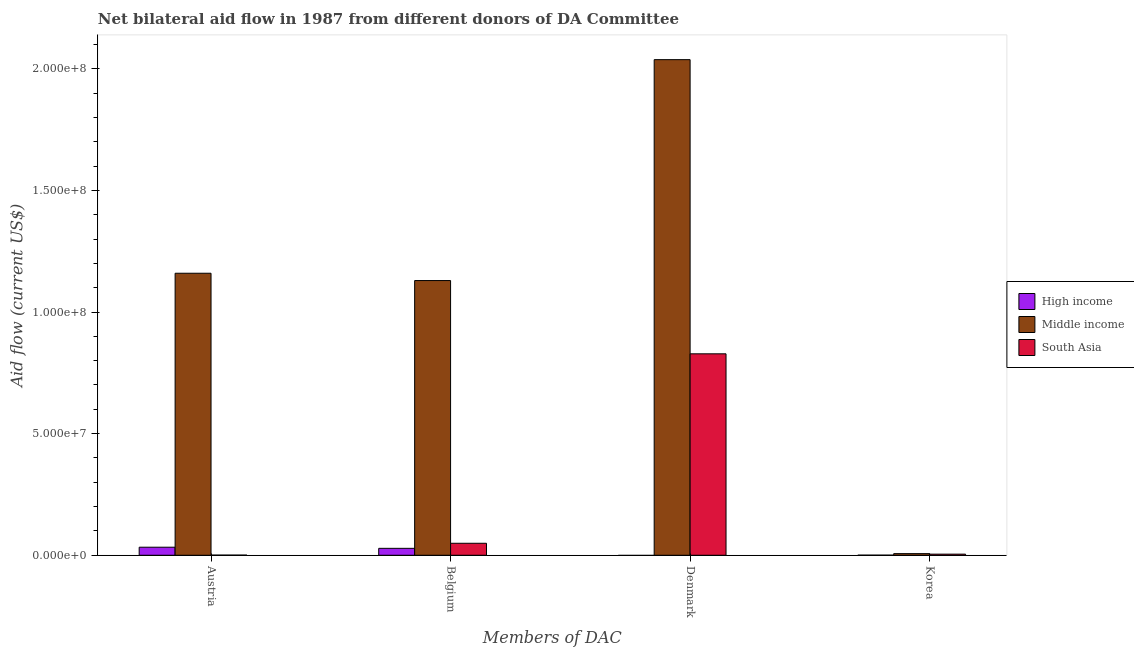Are the number of bars per tick equal to the number of legend labels?
Provide a succinct answer. No. Are the number of bars on each tick of the X-axis equal?
Provide a short and direct response. No. What is the amount of aid given by austria in South Asia?
Make the answer very short. 6.00e+04. Across all countries, what is the maximum amount of aid given by denmark?
Make the answer very short. 2.04e+08. Across all countries, what is the minimum amount of aid given by belgium?
Your answer should be very brief. 2.85e+06. What is the total amount of aid given by austria in the graph?
Offer a terse response. 1.19e+08. What is the difference between the amount of aid given by belgium in Middle income and that in South Asia?
Offer a very short reply. 1.08e+08. What is the difference between the amount of aid given by denmark in Middle income and the amount of aid given by austria in South Asia?
Provide a succinct answer. 2.04e+08. What is the average amount of aid given by denmark per country?
Your response must be concise. 9.55e+07. What is the difference between the amount of aid given by korea and amount of aid given by denmark in South Asia?
Keep it short and to the point. -8.24e+07. What is the ratio of the amount of aid given by korea in South Asia to that in Middle income?
Offer a terse response. 0.69. What is the difference between the highest and the second highest amount of aid given by belgium?
Your answer should be very brief. 1.08e+08. What is the difference between the highest and the lowest amount of aid given by korea?
Keep it short and to the point. 6.30e+05. In how many countries, is the amount of aid given by belgium greater than the average amount of aid given by belgium taken over all countries?
Give a very brief answer. 1. How many bars are there?
Make the answer very short. 11. Are all the bars in the graph horizontal?
Offer a terse response. No. What is the difference between two consecutive major ticks on the Y-axis?
Provide a short and direct response. 5.00e+07. Are the values on the major ticks of Y-axis written in scientific E-notation?
Keep it short and to the point. Yes. Does the graph contain any zero values?
Your answer should be compact. Yes. Does the graph contain grids?
Offer a terse response. No. Where does the legend appear in the graph?
Your answer should be very brief. Center right. How many legend labels are there?
Provide a short and direct response. 3. What is the title of the graph?
Your answer should be compact. Net bilateral aid flow in 1987 from different donors of DA Committee. What is the label or title of the X-axis?
Make the answer very short. Members of DAC. What is the Aid flow (current US$) in High income in Austria?
Make the answer very short. 3.31e+06. What is the Aid flow (current US$) in Middle income in Austria?
Your answer should be compact. 1.16e+08. What is the Aid flow (current US$) of High income in Belgium?
Your answer should be compact. 2.85e+06. What is the Aid flow (current US$) of Middle income in Belgium?
Provide a succinct answer. 1.13e+08. What is the Aid flow (current US$) in South Asia in Belgium?
Your response must be concise. 4.93e+06. What is the Aid flow (current US$) in High income in Denmark?
Make the answer very short. 0. What is the Aid flow (current US$) of Middle income in Denmark?
Offer a very short reply. 2.04e+08. What is the Aid flow (current US$) in South Asia in Denmark?
Offer a terse response. 8.28e+07. What is the Aid flow (current US$) in Middle income in Korea?
Provide a short and direct response. 6.70e+05. Across all Members of DAC, what is the maximum Aid flow (current US$) of High income?
Ensure brevity in your answer.  3.31e+06. Across all Members of DAC, what is the maximum Aid flow (current US$) in Middle income?
Give a very brief answer. 2.04e+08. Across all Members of DAC, what is the maximum Aid flow (current US$) of South Asia?
Offer a very short reply. 8.28e+07. Across all Members of DAC, what is the minimum Aid flow (current US$) in High income?
Provide a succinct answer. 0. Across all Members of DAC, what is the minimum Aid flow (current US$) of Middle income?
Ensure brevity in your answer.  6.70e+05. What is the total Aid flow (current US$) of High income in the graph?
Offer a terse response. 6.20e+06. What is the total Aid flow (current US$) of Middle income in the graph?
Offer a very short reply. 4.33e+08. What is the total Aid flow (current US$) in South Asia in the graph?
Provide a short and direct response. 8.83e+07. What is the difference between the Aid flow (current US$) of High income in Austria and that in Belgium?
Your answer should be compact. 4.60e+05. What is the difference between the Aid flow (current US$) in Middle income in Austria and that in Belgium?
Your answer should be very brief. 3.01e+06. What is the difference between the Aid flow (current US$) of South Asia in Austria and that in Belgium?
Provide a short and direct response. -4.87e+06. What is the difference between the Aid flow (current US$) of Middle income in Austria and that in Denmark?
Your answer should be very brief. -8.78e+07. What is the difference between the Aid flow (current US$) in South Asia in Austria and that in Denmark?
Offer a very short reply. -8.28e+07. What is the difference between the Aid flow (current US$) of High income in Austria and that in Korea?
Give a very brief answer. 3.27e+06. What is the difference between the Aid flow (current US$) in Middle income in Austria and that in Korea?
Provide a short and direct response. 1.15e+08. What is the difference between the Aid flow (current US$) of South Asia in Austria and that in Korea?
Your answer should be compact. -4.00e+05. What is the difference between the Aid flow (current US$) in Middle income in Belgium and that in Denmark?
Give a very brief answer. -9.08e+07. What is the difference between the Aid flow (current US$) of South Asia in Belgium and that in Denmark?
Ensure brevity in your answer.  -7.79e+07. What is the difference between the Aid flow (current US$) in High income in Belgium and that in Korea?
Give a very brief answer. 2.81e+06. What is the difference between the Aid flow (current US$) of Middle income in Belgium and that in Korea?
Offer a very short reply. 1.12e+08. What is the difference between the Aid flow (current US$) of South Asia in Belgium and that in Korea?
Your answer should be compact. 4.47e+06. What is the difference between the Aid flow (current US$) of Middle income in Denmark and that in Korea?
Your answer should be compact. 2.03e+08. What is the difference between the Aid flow (current US$) in South Asia in Denmark and that in Korea?
Keep it short and to the point. 8.24e+07. What is the difference between the Aid flow (current US$) of High income in Austria and the Aid flow (current US$) of Middle income in Belgium?
Ensure brevity in your answer.  -1.10e+08. What is the difference between the Aid flow (current US$) of High income in Austria and the Aid flow (current US$) of South Asia in Belgium?
Give a very brief answer. -1.62e+06. What is the difference between the Aid flow (current US$) of Middle income in Austria and the Aid flow (current US$) of South Asia in Belgium?
Give a very brief answer. 1.11e+08. What is the difference between the Aid flow (current US$) in High income in Austria and the Aid flow (current US$) in Middle income in Denmark?
Provide a short and direct response. -2.00e+08. What is the difference between the Aid flow (current US$) in High income in Austria and the Aid flow (current US$) in South Asia in Denmark?
Ensure brevity in your answer.  -7.95e+07. What is the difference between the Aid flow (current US$) in Middle income in Austria and the Aid flow (current US$) in South Asia in Denmark?
Offer a very short reply. 3.31e+07. What is the difference between the Aid flow (current US$) in High income in Austria and the Aid flow (current US$) in Middle income in Korea?
Offer a very short reply. 2.64e+06. What is the difference between the Aid flow (current US$) of High income in Austria and the Aid flow (current US$) of South Asia in Korea?
Ensure brevity in your answer.  2.85e+06. What is the difference between the Aid flow (current US$) of Middle income in Austria and the Aid flow (current US$) of South Asia in Korea?
Provide a succinct answer. 1.15e+08. What is the difference between the Aid flow (current US$) of High income in Belgium and the Aid flow (current US$) of Middle income in Denmark?
Provide a short and direct response. -2.01e+08. What is the difference between the Aid flow (current US$) of High income in Belgium and the Aid flow (current US$) of South Asia in Denmark?
Give a very brief answer. -8.00e+07. What is the difference between the Aid flow (current US$) of Middle income in Belgium and the Aid flow (current US$) of South Asia in Denmark?
Make the answer very short. 3.01e+07. What is the difference between the Aid flow (current US$) of High income in Belgium and the Aid flow (current US$) of Middle income in Korea?
Offer a terse response. 2.18e+06. What is the difference between the Aid flow (current US$) of High income in Belgium and the Aid flow (current US$) of South Asia in Korea?
Keep it short and to the point. 2.39e+06. What is the difference between the Aid flow (current US$) of Middle income in Belgium and the Aid flow (current US$) of South Asia in Korea?
Give a very brief answer. 1.12e+08. What is the difference between the Aid flow (current US$) of Middle income in Denmark and the Aid flow (current US$) of South Asia in Korea?
Your response must be concise. 2.03e+08. What is the average Aid flow (current US$) in High income per Members of DAC?
Your response must be concise. 1.55e+06. What is the average Aid flow (current US$) of Middle income per Members of DAC?
Keep it short and to the point. 1.08e+08. What is the average Aid flow (current US$) in South Asia per Members of DAC?
Keep it short and to the point. 2.21e+07. What is the difference between the Aid flow (current US$) in High income and Aid flow (current US$) in Middle income in Austria?
Make the answer very short. -1.13e+08. What is the difference between the Aid flow (current US$) in High income and Aid flow (current US$) in South Asia in Austria?
Provide a succinct answer. 3.25e+06. What is the difference between the Aid flow (current US$) of Middle income and Aid flow (current US$) of South Asia in Austria?
Offer a terse response. 1.16e+08. What is the difference between the Aid flow (current US$) of High income and Aid flow (current US$) of Middle income in Belgium?
Give a very brief answer. -1.10e+08. What is the difference between the Aid flow (current US$) of High income and Aid flow (current US$) of South Asia in Belgium?
Offer a very short reply. -2.08e+06. What is the difference between the Aid flow (current US$) in Middle income and Aid flow (current US$) in South Asia in Belgium?
Offer a terse response. 1.08e+08. What is the difference between the Aid flow (current US$) in Middle income and Aid flow (current US$) in South Asia in Denmark?
Keep it short and to the point. 1.21e+08. What is the difference between the Aid flow (current US$) of High income and Aid flow (current US$) of Middle income in Korea?
Provide a succinct answer. -6.30e+05. What is the difference between the Aid flow (current US$) in High income and Aid flow (current US$) in South Asia in Korea?
Make the answer very short. -4.20e+05. What is the difference between the Aid flow (current US$) in Middle income and Aid flow (current US$) in South Asia in Korea?
Keep it short and to the point. 2.10e+05. What is the ratio of the Aid flow (current US$) in High income in Austria to that in Belgium?
Keep it short and to the point. 1.16. What is the ratio of the Aid flow (current US$) of Middle income in Austria to that in Belgium?
Your answer should be compact. 1.03. What is the ratio of the Aid flow (current US$) in South Asia in Austria to that in Belgium?
Your response must be concise. 0.01. What is the ratio of the Aid flow (current US$) of Middle income in Austria to that in Denmark?
Keep it short and to the point. 0.57. What is the ratio of the Aid flow (current US$) in South Asia in Austria to that in Denmark?
Ensure brevity in your answer.  0. What is the ratio of the Aid flow (current US$) of High income in Austria to that in Korea?
Your response must be concise. 82.75. What is the ratio of the Aid flow (current US$) of Middle income in Austria to that in Korea?
Your response must be concise. 173.06. What is the ratio of the Aid flow (current US$) of South Asia in Austria to that in Korea?
Offer a terse response. 0.13. What is the ratio of the Aid flow (current US$) of Middle income in Belgium to that in Denmark?
Offer a very short reply. 0.55. What is the ratio of the Aid flow (current US$) in South Asia in Belgium to that in Denmark?
Your answer should be very brief. 0.06. What is the ratio of the Aid flow (current US$) in High income in Belgium to that in Korea?
Provide a succinct answer. 71.25. What is the ratio of the Aid flow (current US$) in Middle income in Belgium to that in Korea?
Give a very brief answer. 168.57. What is the ratio of the Aid flow (current US$) in South Asia in Belgium to that in Korea?
Provide a short and direct response. 10.72. What is the ratio of the Aid flow (current US$) of Middle income in Denmark to that in Korea?
Your response must be concise. 304.12. What is the ratio of the Aid flow (current US$) of South Asia in Denmark to that in Korea?
Offer a terse response. 180.04. What is the difference between the highest and the second highest Aid flow (current US$) in Middle income?
Provide a short and direct response. 8.78e+07. What is the difference between the highest and the second highest Aid flow (current US$) in South Asia?
Give a very brief answer. 7.79e+07. What is the difference between the highest and the lowest Aid flow (current US$) in High income?
Keep it short and to the point. 3.31e+06. What is the difference between the highest and the lowest Aid flow (current US$) of Middle income?
Offer a terse response. 2.03e+08. What is the difference between the highest and the lowest Aid flow (current US$) in South Asia?
Keep it short and to the point. 8.28e+07. 